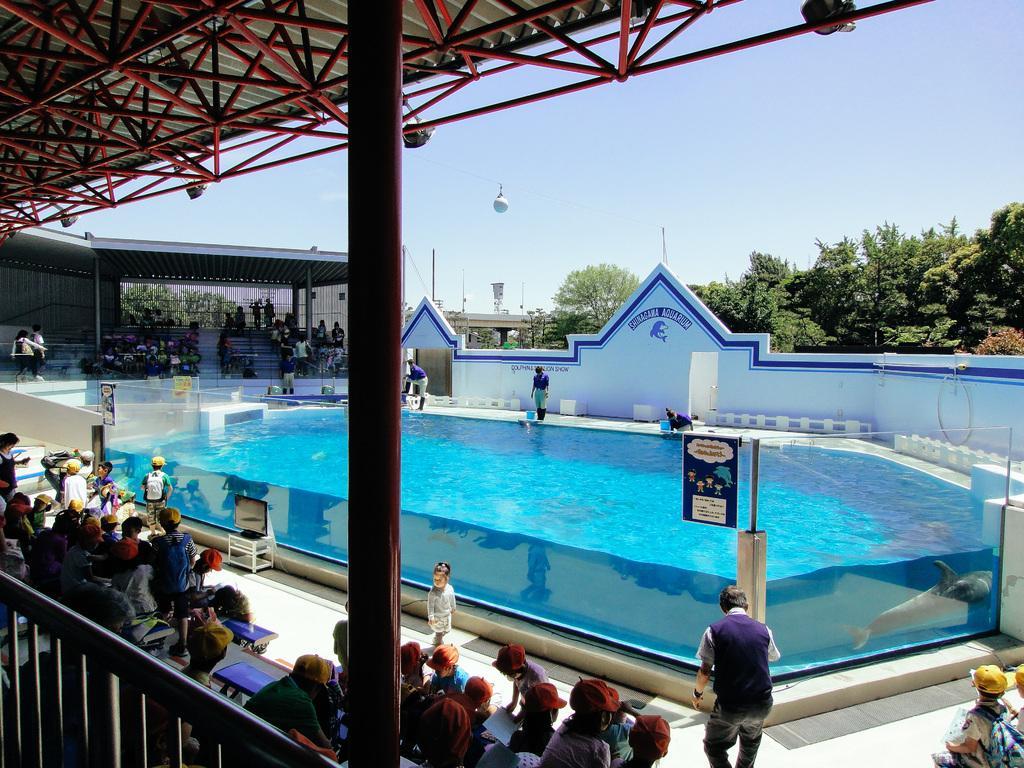Please provide a concise description of this image. In this image, we can see a dolphin in the pool and in the background, there are many people and some are wearing caps and we can see a railing, sheds, stairs, boards, stands, trees, poles and there is a wall and there is a parachute. At the top, there is sky. 